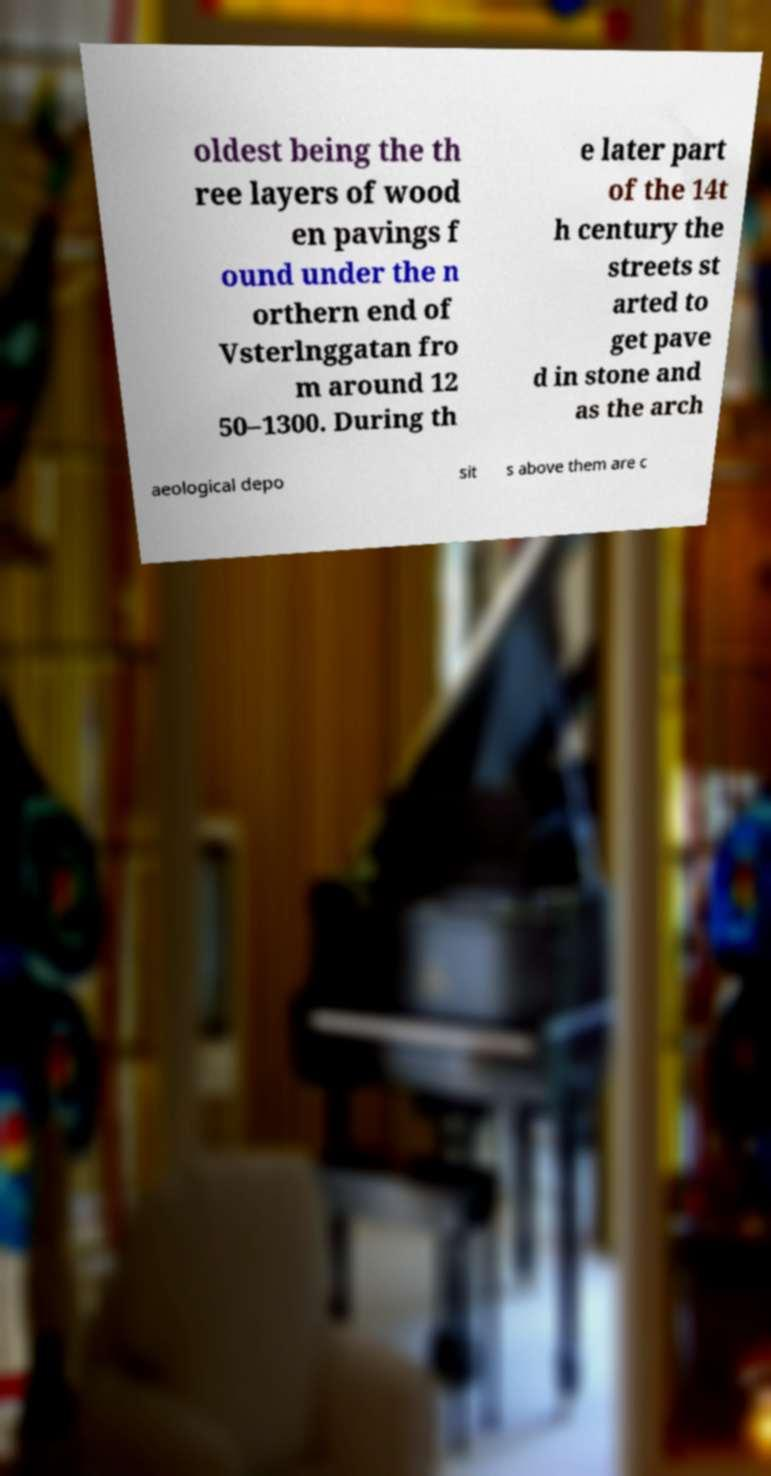For documentation purposes, I need the text within this image transcribed. Could you provide that? oldest being the th ree layers of wood en pavings f ound under the n orthern end of Vsterlnggatan fro m around 12 50–1300. During th e later part of the 14t h century the streets st arted to get pave d in stone and as the arch aeological depo sit s above them are c 